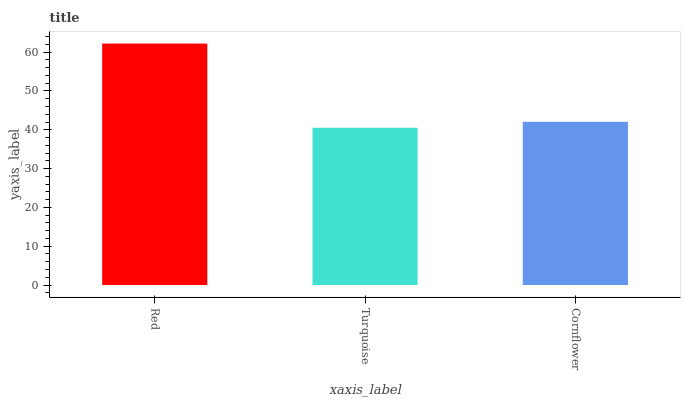Is Turquoise the minimum?
Answer yes or no. Yes. Is Red the maximum?
Answer yes or no. Yes. Is Cornflower the minimum?
Answer yes or no. No. Is Cornflower the maximum?
Answer yes or no. No. Is Cornflower greater than Turquoise?
Answer yes or no. Yes. Is Turquoise less than Cornflower?
Answer yes or no. Yes. Is Turquoise greater than Cornflower?
Answer yes or no. No. Is Cornflower less than Turquoise?
Answer yes or no. No. Is Cornflower the high median?
Answer yes or no. Yes. Is Cornflower the low median?
Answer yes or no. Yes. Is Red the high median?
Answer yes or no. No. Is Red the low median?
Answer yes or no. No. 